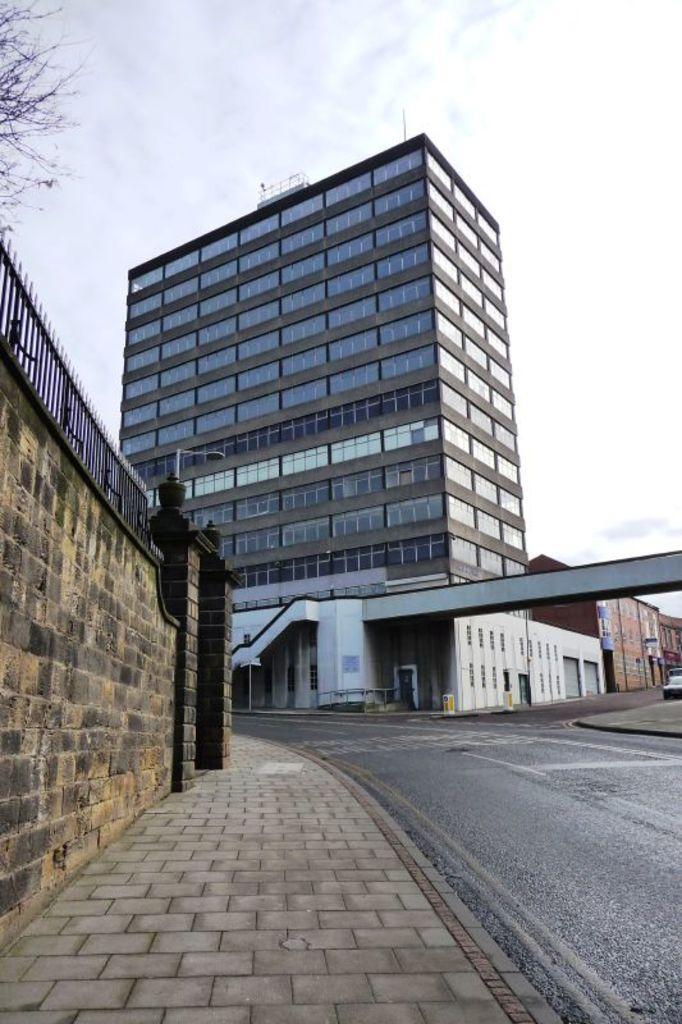Can you describe this image briefly? In this image we can see buildings, road, pavement, wall and a tree on the left side of the picture and a sky in the background. 